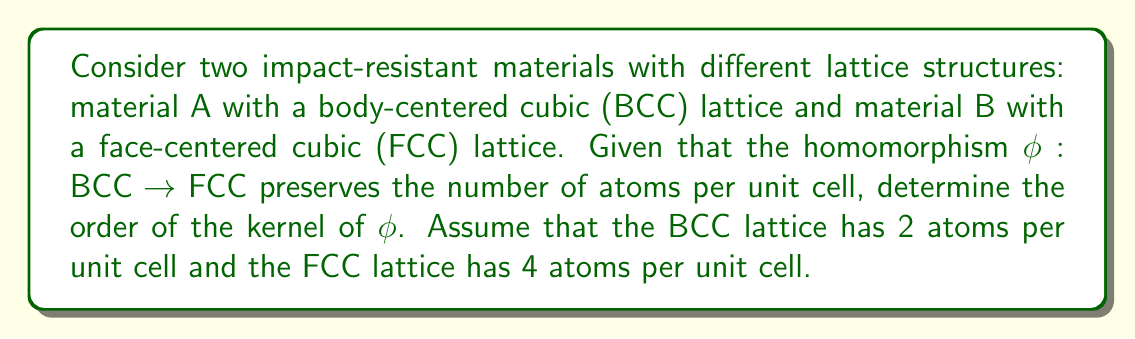Can you solve this math problem? To solve this problem, we need to understand the concept of homomorphisms in abstract algebra and apply it to the given lattice structures. Let's break it down step-by-step:

1) A homomorphism is a structure-preserving map between two algebraic structures. In this case, we're dealing with a homomorphism between lattice structures.

2) The given homomorphism $\phi: BCC \rightarrow FCC$ preserves the number of atoms per unit cell. This means that the image of each element in the BCC lattice corresponds to an element in the FCC lattice with the same number of atoms.

3) We're given that:
   - BCC lattice has 2 atoms per unit cell
   - FCC lattice has 4 atoms per unit cell

4) The kernel of a homomorphism $\phi$ is defined as the set of all elements in the domain that map to the identity element in the codomain. In this case, it would be all elements in the BCC lattice that map to a structure in the FCC lattice with no atoms.

5) Since $\phi$ preserves the number of atoms, and there's no way to map 2 atoms to 0 atoms while preserving the count, the kernel must be trivial (containing only the identity element).

6) The order of a group is the number of elements in the group. For a trivial group (kernel in this case), the order is 1.

Therefore, the order of the kernel of $\phi$ is 1.
Answer: The order of the kernel of $\phi$ is 1. 